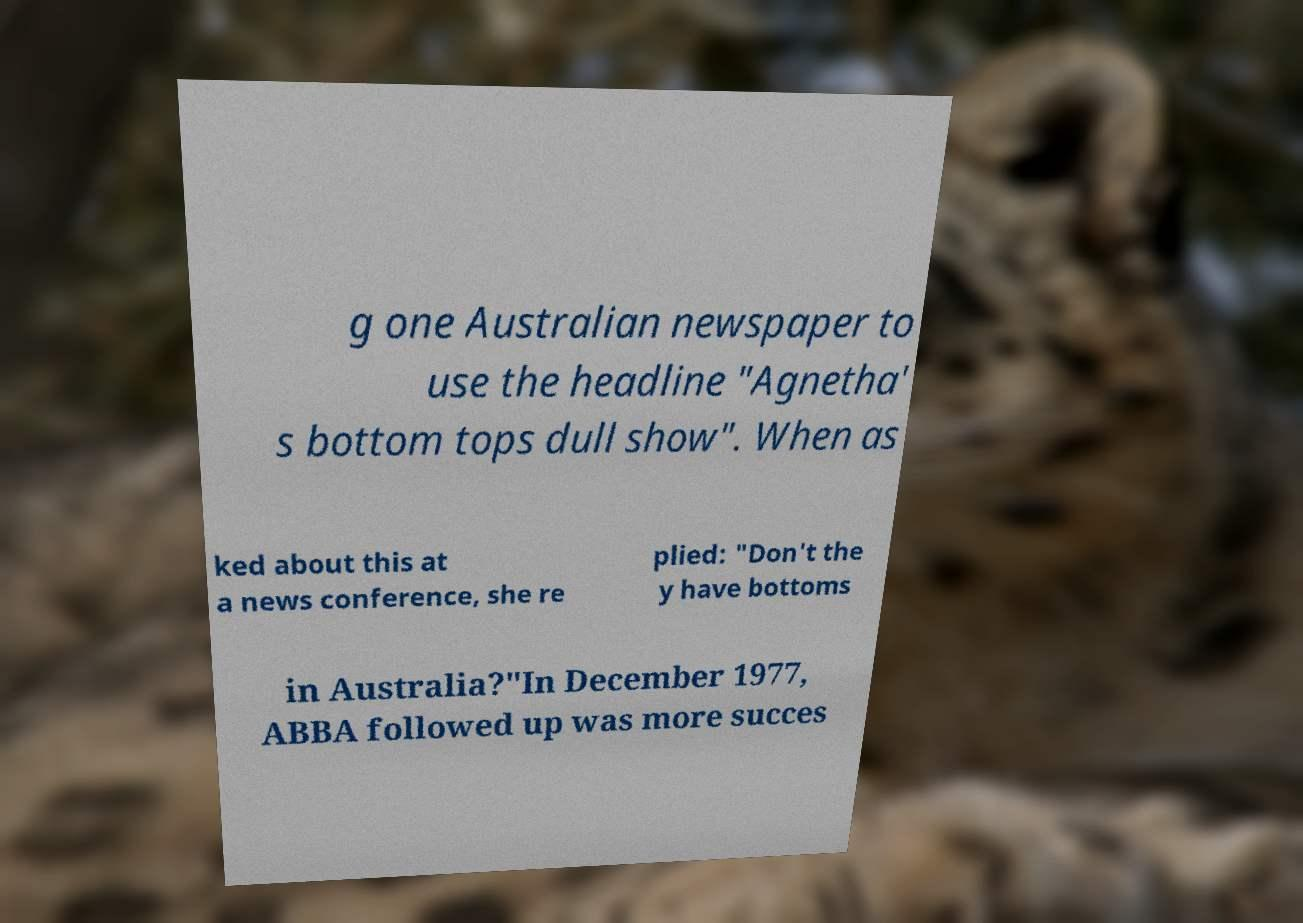Please identify and transcribe the text found in this image. g one Australian newspaper to use the headline "Agnetha' s bottom tops dull show". When as ked about this at a news conference, she re plied: "Don't the y have bottoms in Australia?"In December 1977, ABBA followed up was more succes 